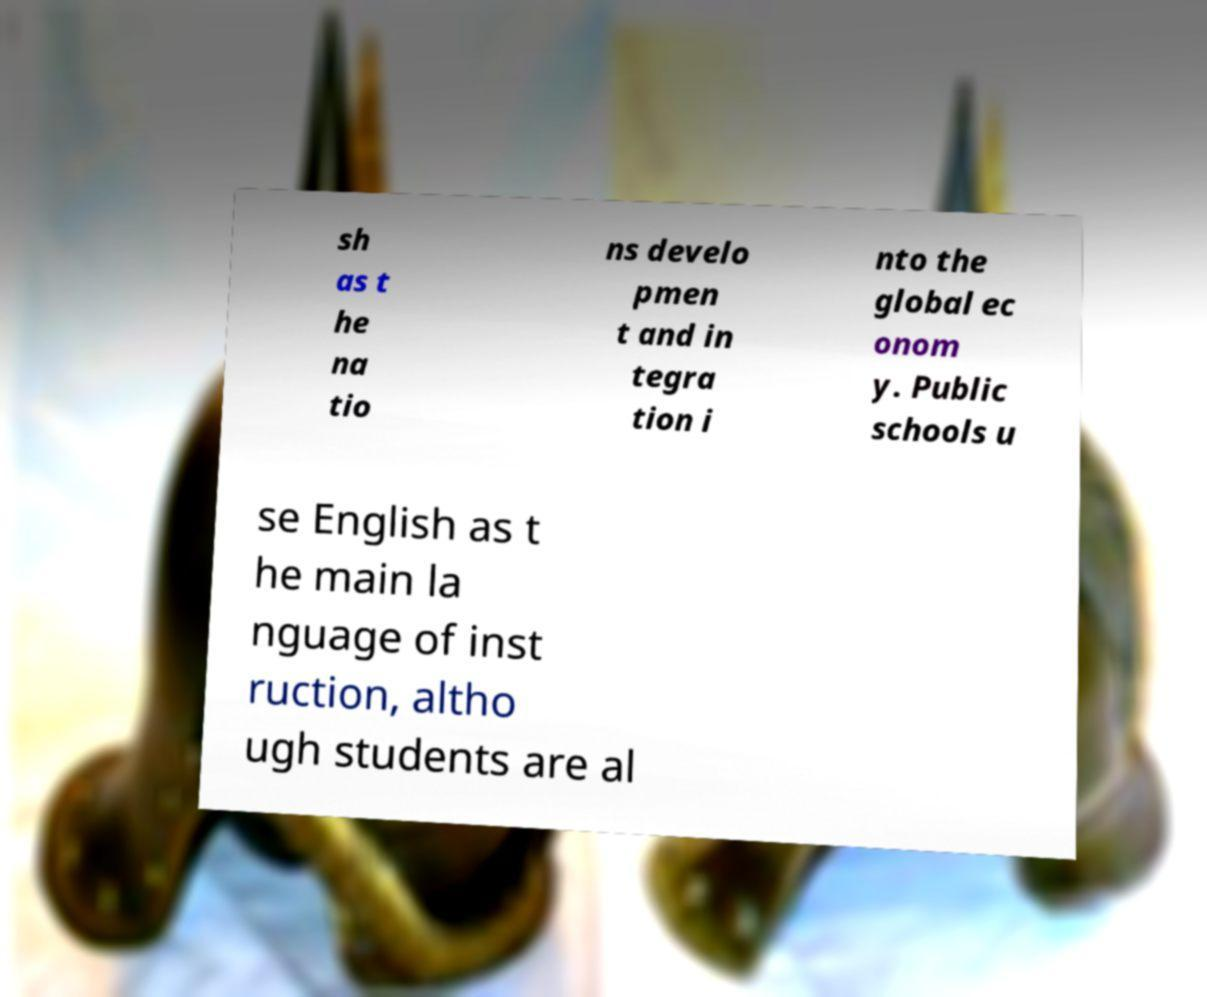Please read and relay the text visible in this image. What does it say? sh as t he na tio ns develo pmen t and in tegra tion i nto the global ec onom y. Public schools u se English as t he main la nguage of inst ruction, altho ugh students are al 